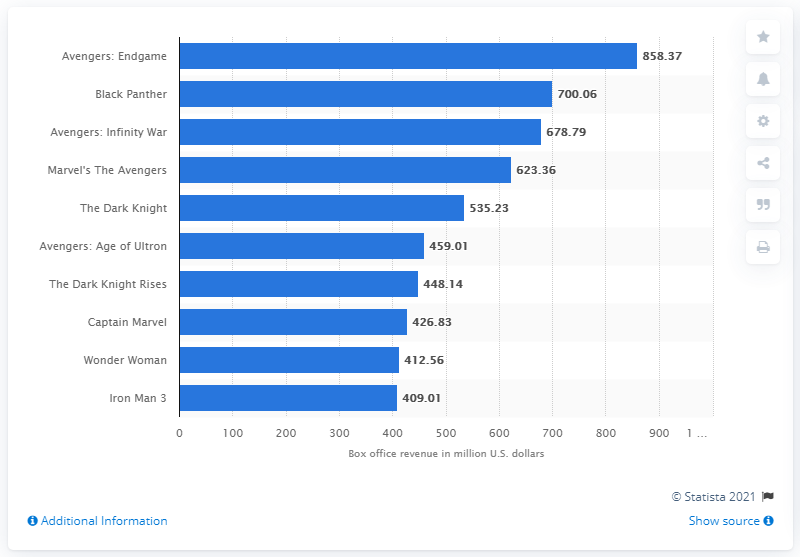Give some essential details in this illustration. According to financial records, Avengers: Endgame grossed a total of 858.37 U.S. dollars in the United States. The box office revenue of Black Panther was approximately $700.06 million. 